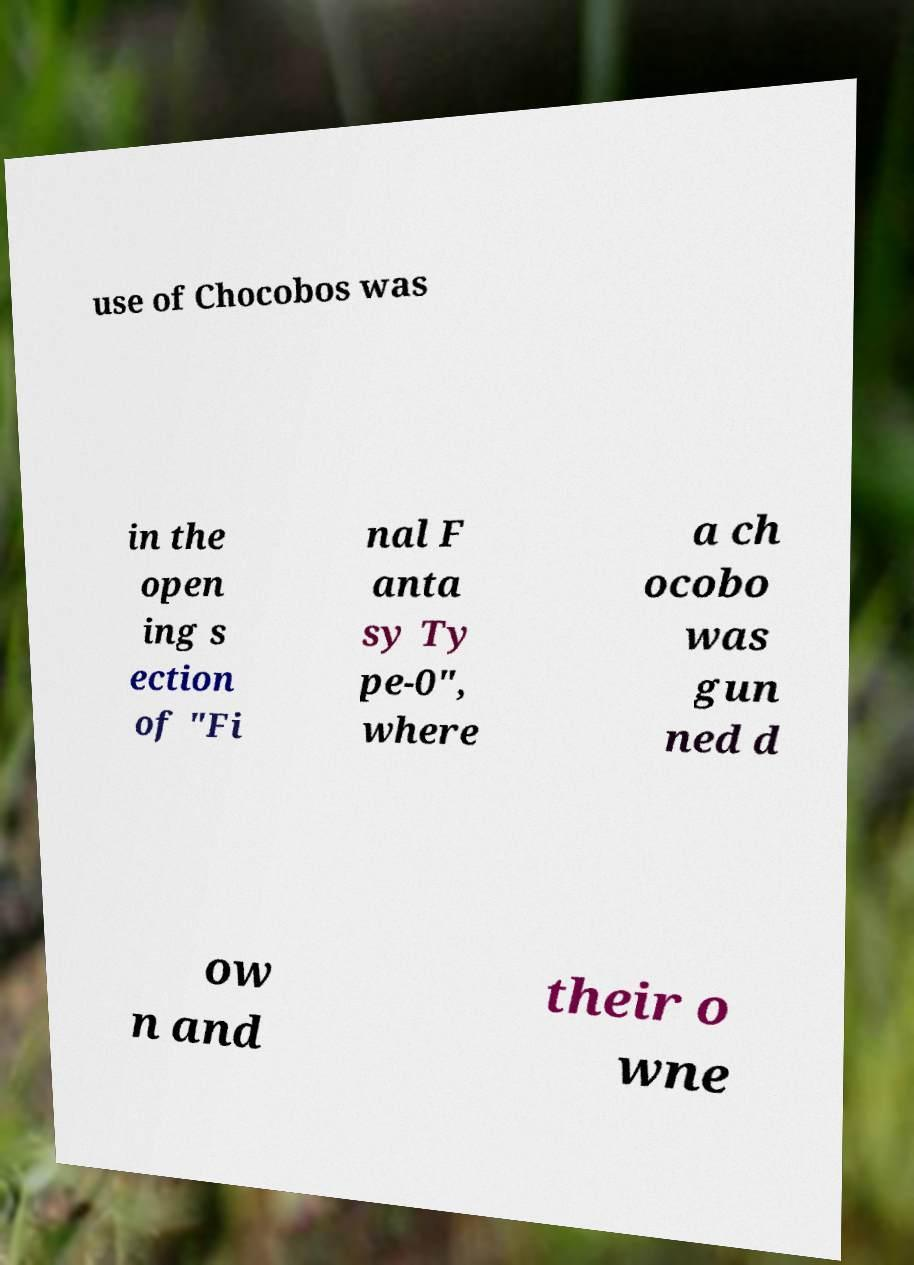Can you read and provide the text displayed in the image?This photo seems to have some interesting text. Can you extract and type it out for me? use of Chocobos was in the open ing s ection of "Fi nal F anta sy Ty pe-0", where a ch ocobo was gun ned d ow n and their o wne 